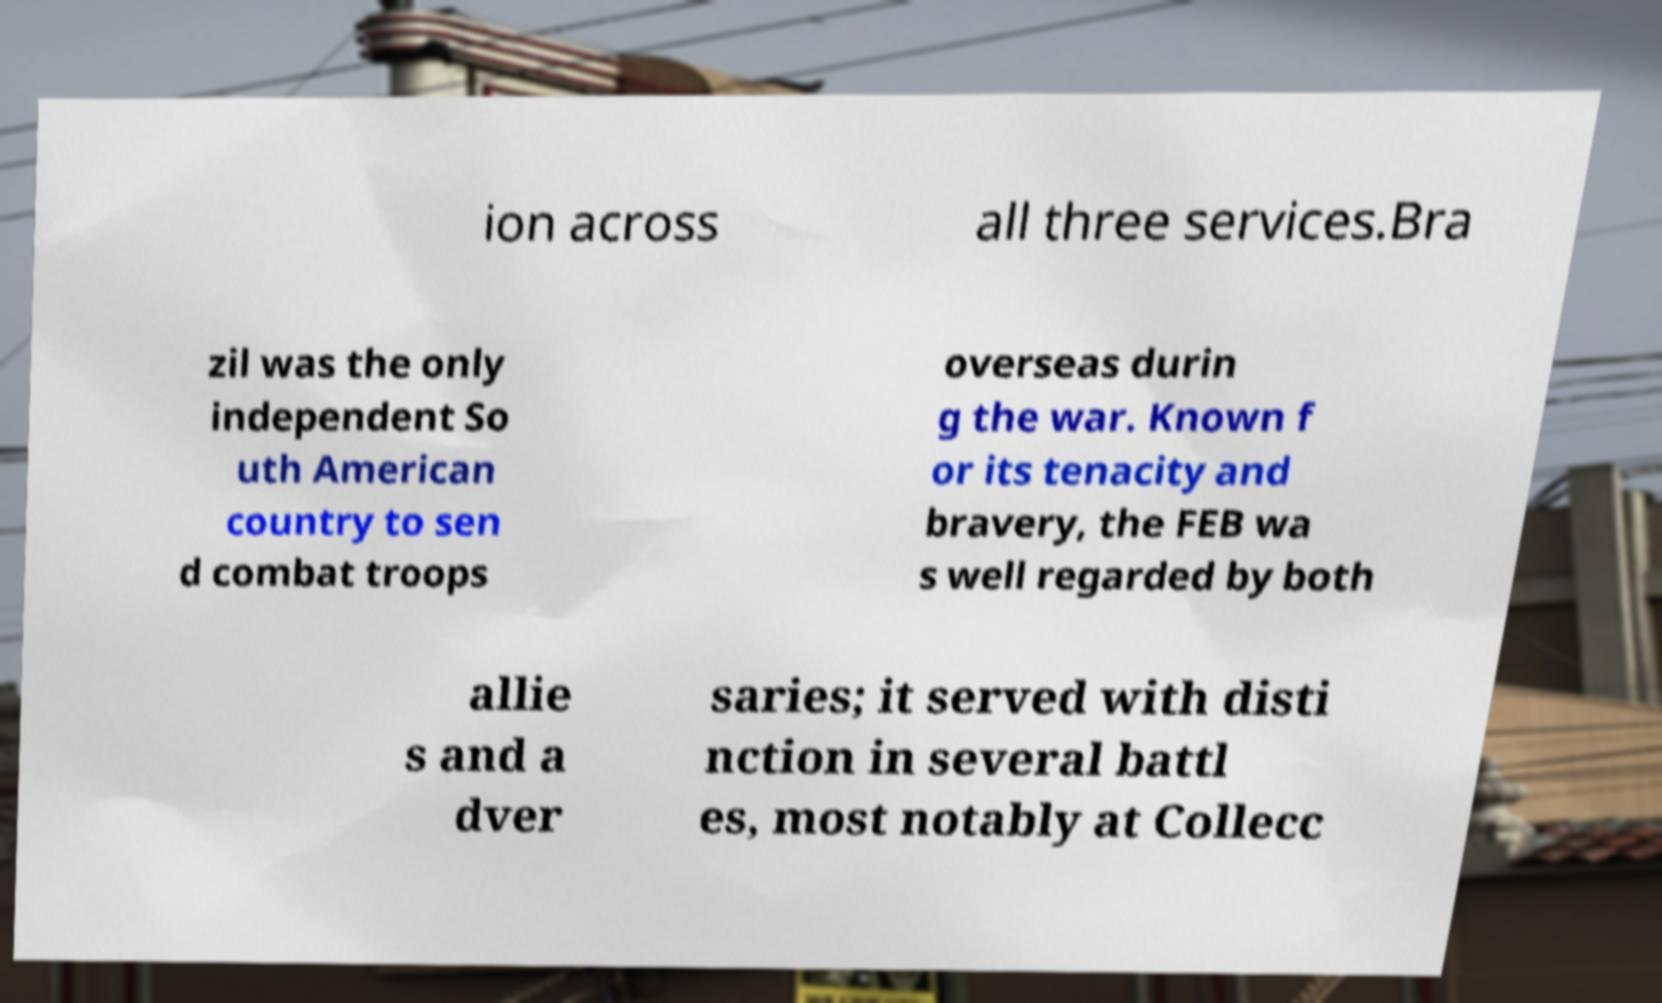Please read and relay the text visible in this image. What does it say? ion across all three services.Bra zil was the only independent So uth American country to sen d combat troops overseas durin g the war. Known f or its tenacity and bravery, the FEB wa s well regarded by both allie s and a dver saries; it served with disti nction in several battl es, most notably at Collecc 